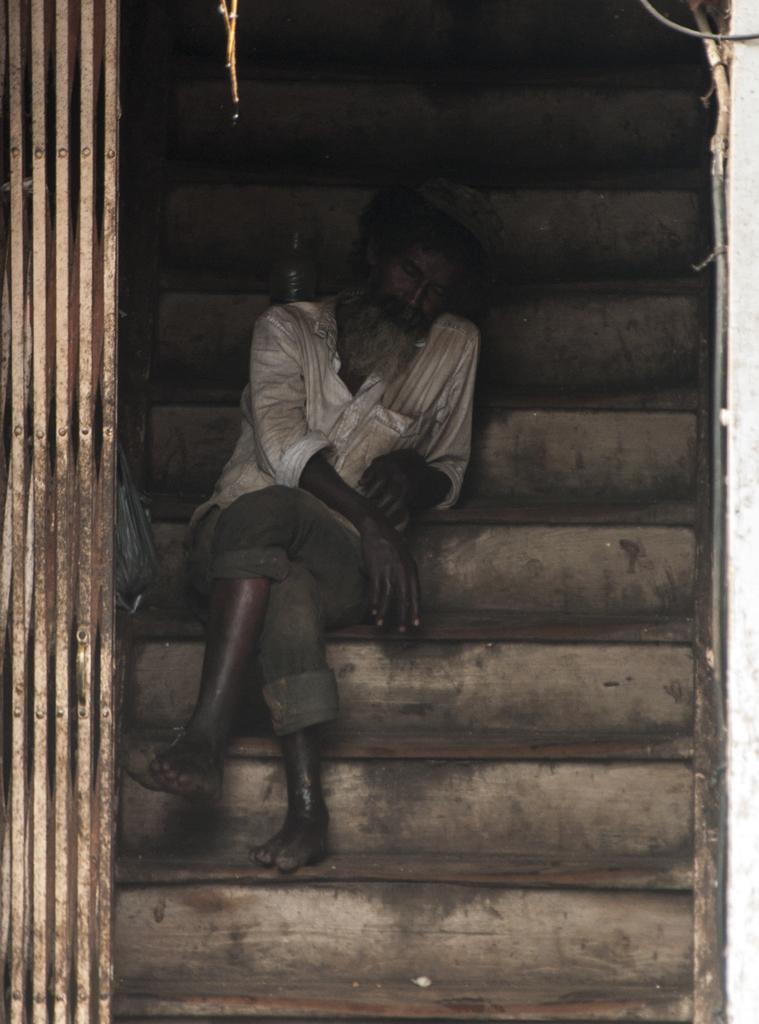Describe this image in one or two sentences. Here, we can see some stars, there is a man sitting on the stairs, at the left side there is a metal grill. 